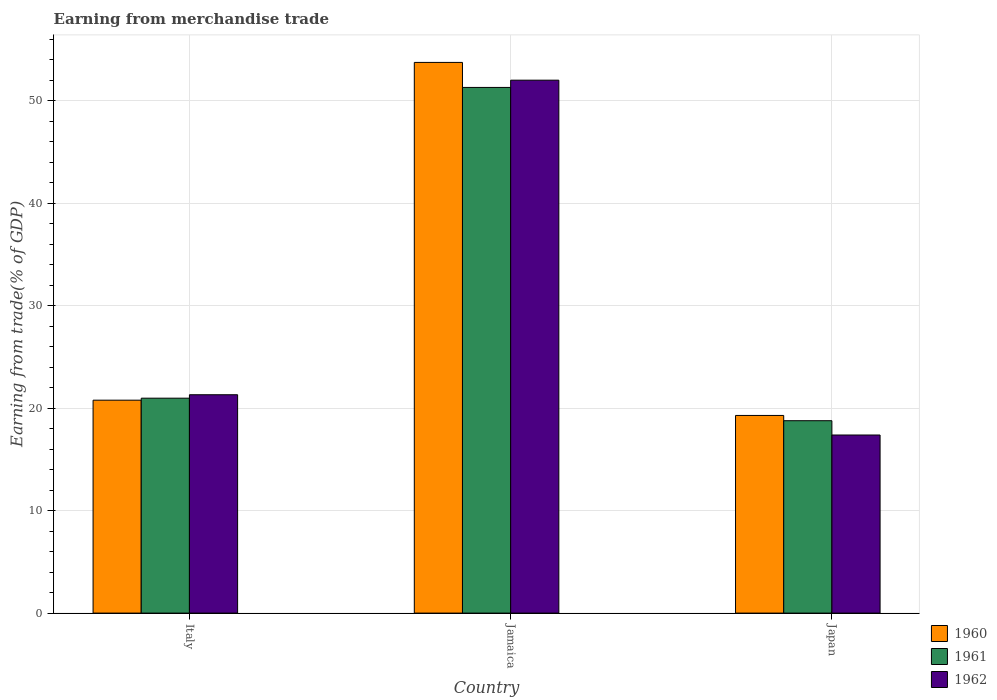How many groups of bars are there?
Give a very brief answer. 3. Are the number of bars per tick equal to the number of legend labels?
Offer a very short reply. Yes. Are the number of bars on each tick of the X-axis equal?
Your response must be concise. Yes. How many bars are there on the 2nd tick from the left?
Give a very brief answer. 3. What is the label of the 1st group of bars from the left?
Ensure brevity in your answer.  Italy. In how many cases, is the number of bars for a given country not equal to the number of legend labels?
Provide a short and direct response. 0. What is the earnings from trade in 1960 in Japan?
Give a very brief answer. 19.29. Across all countries, what is the maximum earnings from trade in 1962?
Provide a short and direct response. 52. Across all countries, what is the minimum earnings from trade in 1962?
Provide a short and direct response. 17.38. In which country was the earnings from trade in 1961 maximum?
Ensure brevity in your answer.  Jamaica. In which country was the earnings from trade in 1960 minimum?
Offer a terse response. Japan. What is the total earnings from trade in 1961 in the graph?
Provide a short and direct response. 91.04. What is the difference between the earnings from trade in 1960 in Italy and that in Jamaica?
Provide a succinct answer. -32.96. What is the difference between the earnings from trade in 1961 in Italy and the earnings from trade in 1960 in Japan?
Your answer should be very brief. 1.69. What is the average earnings from trade in 1962 per country?
Make the answer very short. 30.23. What is the difference between the earnings from trade of/in 1961 and earnings from trade of/in 1962 in Japan?
Your response must be concise. 1.4. What is the ratio of the earnings from trade in 1962 in Italy to that in Japan?
Offer a very short reply. 1.23. Is the difference between the earnings from trade in 1961 in Jamaica and Japan greater than the difference between the earnings from trade in 1962 in Jamaica and Japan?
Keep it short and to the point. No. What is the difference between the highest and the second highest earnings from trade in 1962?
Offer a terse response. -34.63. What is the difference between the highest and the lowest earnings from trade in 1962?
Provide a short and direct response. 34.63. In how many countries, is the earnings from trade in 1962 greater than the average earnings from trade in 1962 taken over all countries?
Give a very brief answer. 1. Is the sum of the earnings from trade in 1962 in Italy and Jamaica greater than the maximum earnings from trade in 1960 across all countries?
Ensure brevity in your answer.  Yes. What does the 3rd bar from the left in Japan represents?
Keep it short and to the point. 1962. What does the 2nd bar from the right in Italy represents?
Offer a terse response. 1961. Are all the bars in the graph horizontal?
Keep it short and to the point. No. How many countries are there in the graph?
Your answer should be compact. 3. Does the graph contain any zero values?
Keep it short and to the point. No. Does the graph contain grids?
Your answer should be compact. Yes. How many legend labels are there?
Keep it short and to the point. 3. What is the title of the graph?
Your answer should be very brief. Earning from merchandise trade. Does "2004" appear as one of the legend labels in the graph?
Keep it short and to the point. No. What is the label or title of the Y-axis?
Ensure brevity in your answer.  Earning from trade(% of GDP). What is the Earning from trade(% of GDP) in 1960 in Italy?
Your response must be concise. 20.78. What is the Earning from trade(% of GDP) in 1961 in Italy?
Ensure brevity in your answer.  20.97. What is the Earning from trade(% of GDP) of 1962 in Italy?
Your response must be concise. 21.31. What is the Earning from trade(% of GDP) in 1960 in Jamaica?
Your answer should be compact. 53.74. What is the Earning from trade(% of GDP) in 1961 in Jamaica?
Your answer should be very brief. 51.3. What is the Earning from trade(% of GDP) of 1962 in Jamaica?
Keep it short and to the point. 52. What is the Earning from trade(% of GDP) in 1960 in Japan?
Offer a very short reply. 19.29. What is the Earning from trade(% of GDP) of 1961 in Japan?
Ensure brevity in your answer.  18.77. What is the Earning from trade(% of GDP) in 1962 in Japan?
Your answer should be compact. 17.38. Across all countries, what is the maximum Earning from trade(% of GDP) of 1960?
Ensure brevity in your answer.  53.74. Across all countries, what is the maximum Earning from trade(% of GDP) of 1961?
Your answer should be very brief. 51.3. Across all countries, what is the maximum Earning from trade(% of GDP) of 1962?
Your answer should be very brief. 52. Across all countries, what is the minimum Earning from trade(% of GDP) of 1960?
Give a very brief answer. 19.29. Across all countries, what is the minimum Earning from trade(% of GDP) of 1961?
Make the answer very short. 18.77. Across all countries, what is the minimum Earning from trade(% of GDP) of 1962?
Your answer should be very brief. 17.38. What is the total Earning from trade(% of GDP) in 1960 in the graph?
Your answer should be very brief. 93.8. What is the total Earning from trade(% of GDP) in 1961 in the graph?
Provide a short and direct response. 91.04. What is the total Earning from trade(% of GDP) in 1962 in the graph?
Your answer should be compact. 90.69. What is the difference between the Earning from trade(% of GDP) of 1960 in Italy and that in Jamaica?
Make the answer very short. -32.96. What is the difference between the Earning from trade(% of GDP) of 1961 in Italy and that in Jamaica?
Give a very brief answer. -30.32. What is the difference between the Earning from trade(% of GDP) in 1962 in Italy and that in Jamaica?
Keep it short and to the point. -30.7. What is the difference between the Earning from trade(% of GDP) in 1960 in Italy and that in Japan?
Offer a terse response. 1.49. What is the difference between the Earning from trade(% of GDP) in 1961 in Italy and that in Japan?
Offer a terse response. 2.2. What is the difference between the Earning from trade(% of GDP) of 1962 in Italy and that in Japan?
Ensure brevity in your answer.  3.93. What is the difference between the Earning from trade(% of GDP) in 1960 in Jamaica and that in Japan?
Your answer should be compact. 34.45. What is the difference between the Earning from trade(% of GDP) of 1961 in Jamaica and that in Japan?
Your answer should be compact. 32.52. What is the difference between the Earning from trade(% of GDP) of 1962 in Jamaica and that in Japan?
Make the answer very short. 34.63. What is the difference between the Earning from trade(% of GDP) of 1960 in Italy and the Earning from trade(% of GDP) of 1961 in Jamaica?
Give a very brief answer. -30.52. What is the difference between the Earning from trade(% of GDP) of 1960 in Italy and the Earning from trade(% of GDP) of 1962 in Jamaica?
Your answer should be very brief. -31.23. What is the difference between the Earning from trade(% of GDP) in 1961 in Italy and the Earning from trade(% of GDP) in 1962 in Jamaica?
Offer a very short reply. -31.03. What is the difference between the Earning from trade(% of GDP) of 1960 in Italy and the Earning from trade(% of GDP) of 1961 in Japan?
Your response must be concise. 2. What is the difference between the Earning from trade(% of GDP) in 1960 in Italy and the Earning from trade(% of GDP) in 1962 in Japan?
Give a very brief answer. 3.4. What is the difference between the Earning from trade(% of GDP) in 1961 in Italy and the Earning from trade(% of GDP) in 1962 in Japan?
Give a very brief answer. 3.59. What is the difference between the Earning from trade(% of GDP) in 1960 in Jamaica and the Earning from trade(% of GDP) in 1961 in Japan?
Keep it short and to the point. 34.96. What is the difference between the Earning from trade(% of GDP) in 1960 in Jamaica and the Earning from trade(% of GDP) in 1962 in Japan?
Your answer should be very brief. 36.36. What is the difference between the Earning from trade(% of GDP) of 1961 in Jamaica and the Earning from trade(% of GDP) of 1962 in Japan?
Your answer should be very brief. 33.92. What is the average Earning from trade(% of GDP) in 1960 per country?
Offer a very short reply. 31.27. What is the average Earning from trade(% of GDP) in 1961 per country?
Ensure brevity in your answer.  30.35. What is the average Earning from trade(% of GDP) in 1962 per country?
Give a very brief answer. 30.23. What is the difference between the Earning from trade(% of GDP) in 1960 and Earning from trade(% of GDP) in 1961 in Italy?
Provide a succinct answer. -0.2. What is the difference between the Earning from trade(% of GDP) of 1960 and Earning from trade(% of GDP) of 1962 in Italy?
Make the answer very short. -0.53. What is the difference between the Earning from trade(% of GDP) in 1961 and Earning from trade(% of GDP) in 1962 in Italy?
Your answer should be very brief. -0.34. What is the difference between the Earning from trade(% of GDP) of 1960 and Earning from trade(% of GDP) of 1961 in Jamaica?
Provide a short and direct response. 2.44. What is the difference between the Earning from trade(% of GDP) of 1960 and Earning from trade(% of GDP) of 1962 in Jamaica?
Provide a short and direct response. 1.73. What is the difference between the Earning from trade(% of GDP) in 1961 and Earning from trade(% of GDP) in 1962 in Jamaica?
Make the answer very short. -0.71. What is the difference between the Earning from trade(% of GDP) in 1960 and Earning from trade(% of GDP) in 1961 in Japan?
Ensure brevity in your answer.  0.51. What is the difference between the Earning from trade(% of GDP) in 1960 and Earning from trade(% of GDP) in 1962 in Japan?
Give a very brief answer. 1.91. What is the difference between the Earning from trade(% of GDP) of 1961 and Earning from trade(% of GDP) of 1962 in Japan?
Your answer should be compact. 1.4. What is the ratio of the Earning from trade(% of GDP) in 1960 in Italy to that in Jamaica?
Make the answer very short. 0.39. What is the ratio of the Earning from trade(% of GDP) in 1961 in Italy to that in Jamaica?
Give a very brief answer. 0.41. What is the ratio of the Earning from trade(% of GDP) in 1962 in Italy to that in Jamaica?
Make the answer very short. 0.41. What is the ratio of the Earning from trade(% of GDP) in 1960 in Italy to that in Japan?
Offer a terse response. 1.08. What is the ratio of the Earning from trade(% of GDP) in 1961 in Italy to that in Japan?
Offer a very short reply. 1.12. What is the ratio of the Earning from trade(% of GDP) in 1962 in Italy to that in Japan?
Provide a succinct answer. 1.23. What is the ratio of the Earning from trade(% of GDP) in 1960 in Jamaica to that in Japan?
Offer a terse response. 2.79. What is the ratio of the Earning from trade(% of GDP) of 1961 in Jamaica to that in Japan?
Your answer should be compact. 2.73. What is the ratio of the Earning from trade(% of GDP) of 1962 in Jamaica to that in Japan?
Offer a terse response. 2.99. What is the difference between the highest and the second highest Earning from trade(% of GDP) of 1960?
Give a very brief answer. 32.96. What is the difference between the highest and the second highest Earning from trade(% of GDP) in 1961?
Provide a succinct answer. 30.32. What is the difference between the highest and the second highest Earning from trade(% of GDP) of 1962?
Offer a terse response. 30.7. What is the difference between the highest and the lowest Earning from trade(% of GDP) of 1960?
Ensure brevity in your answer.  34.45. What is the difference between the highest and the lowest Earning from trade(% of GDP) of 1961?
Offer a very short reply. 32.52. What is the difference between the highest and the lowest Earning from trade(% of GDP) in 1962?
Provide a short and direct response. 34.63. 